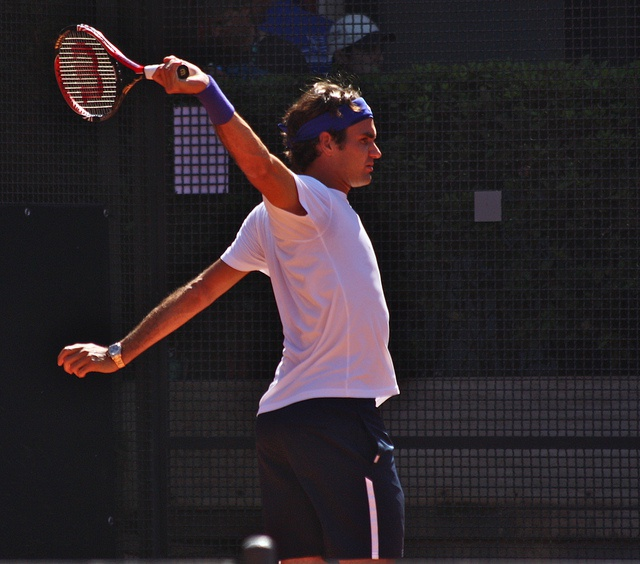Describe the objects in this image and their specific colors. I can see people in black, gray, violet, and maroon tones, tennis racket in black, maroon, brown, and lightgray tones, and clock in black, gray, darkgray, and lightgray tones in this image. 